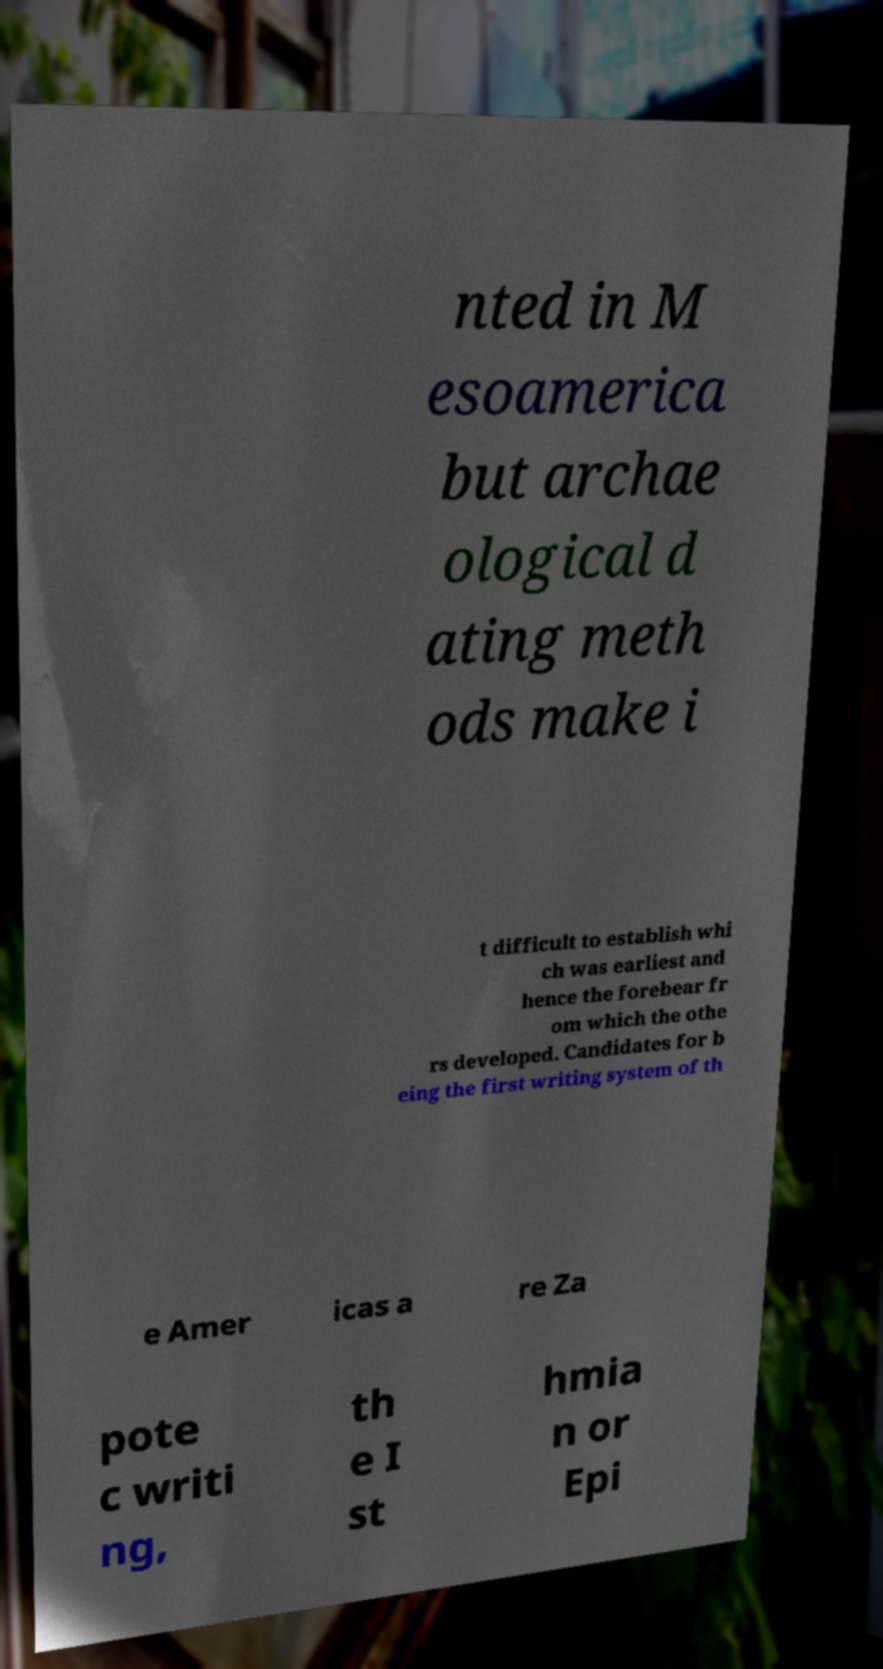Please read and relay the text visible in this image. What does it say? nted in M esoamerica but archae ological d ating meth ods make i t difficult to establish whi ch was earliest and hence the forebear fr om which the othe rs developed. Candidates for b eing the first writing system of th e Amer icas a re Za pote c writi ng, th e I st hmia n or Epi 